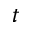<formula> <loc_0><loc_0><loc_500><loc_500>t</formula> 